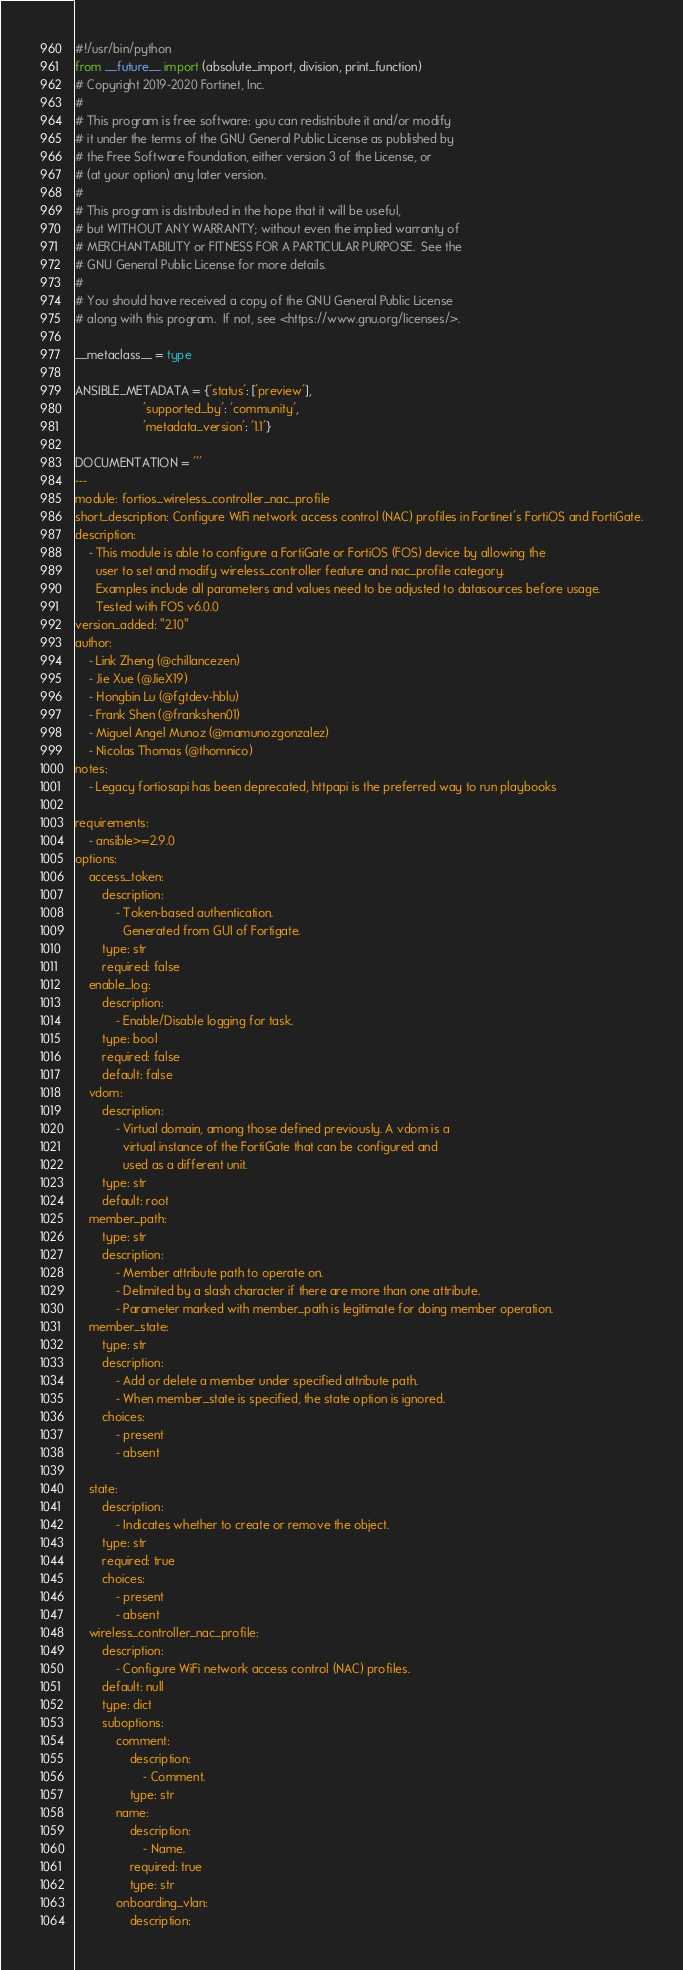Convert code to text. <code><loc_0><loc_0><loc_500><loc_500><_Python_>#!/usr/bin/python
from __future__ import (absolute_import, division, print_function)
# Copyright 2019-2020 Fortinet, Inc.
#
# This program is free software: you can redistribute it and/or modify
# it under the terms of the GNU General Public License as published by
# the Free Software Foundation, either version 3 of the License, or
# (at your option) any later version.
#
# This program is distributed in the hope that it will be useful,
# but WITHOUT ANY WARRANTY; without even the implied warranty of
# MERCHANTABILITY or FITNESS FOR A PARTICULAR PURPOSE.  See the
# GNU General Public License for more details.
#
# You should have received a copy of the GNU General Public License
# along with this program.  If not, see <https://www.gnu.org/licenses/>.

__metaclass__ = type

ANSIBLE_METADATA = {'status': ['preview'],
                    'supported_by': 'community',
                    'metadata_version': '1.1'}

DOCUMENTATION = '''
---
module: fortios_wireless_controller_nac_profile
short_description: Configure WiFi network access control (NAC) profiles in Fortinet's FortiOS and FortiGate.
description:
    - This module is able to configure a FortiGate or FortiOS (FOS) device by allowing the
      user to set and modify wireless_controller feature and nac_profile category.
      Examples include all parameters and values need to be adjusted to datasources before usage.
      Tested with FOS v6.0.0
version_added: "2.10"
author:
    - Link Zheng (@chillancezen)
    - Jie Xue (@JieX19)
    - Hongbin Lu (@fgtdev-hblu)
    - Frank Shen (@frankshen01)
    - Miguel Angel Munoz (@mamunozgonzalez)
    - Nicolas Thomas (@thomnico)
notes:
    - Legacy fortiosapi has been deprecated, httpapi is the preferred way to run playbooks

requirements:
    - ansible>=2.9.0
options:
    access_token:
        description:
            - Token-based authentication.
              Generated from GUI of Fortigate.
        type: str
        required: false
    enable_log:
        description:
            - Enable/Disable logging for task.
        type: bool
        required: false
        default: false
    vdom:
        description:
            - Virtual domain, among those defined previously. A vdom is a
              virtual instance of the FortiGate that can be configured and
              used as a different unit.
        type: str
        default: root
    member_path:
        type: str
        description:
            - Member attribute path to operate on.
            - Delimited by a slash character if there are more than one attribute.
            - Parameter marked with member_path is legitimate for doing member operation.
    member_state:
        type: str
        description:
            - Add or delete a member under specified attribute path.
            - When member_state is specified, the state option is ignored.
        choices:
            - present
            - absent

    state:
        description:
            - Indicates whether to create or remove the object.
        type: str
        required: true
        choices:
            - present
            - absent
    wireless_controller_nac_profile:
        description:
            - Configure WiFi network access control (NAC) profiles.
        default: null
        type: dict
        suboptions:
            comment:
                description:
                    - Comment.
                type: str
            name:
                description:
                    - Name.
                required: true
                type: str
            onboarding_vlan:
                description:</code> 